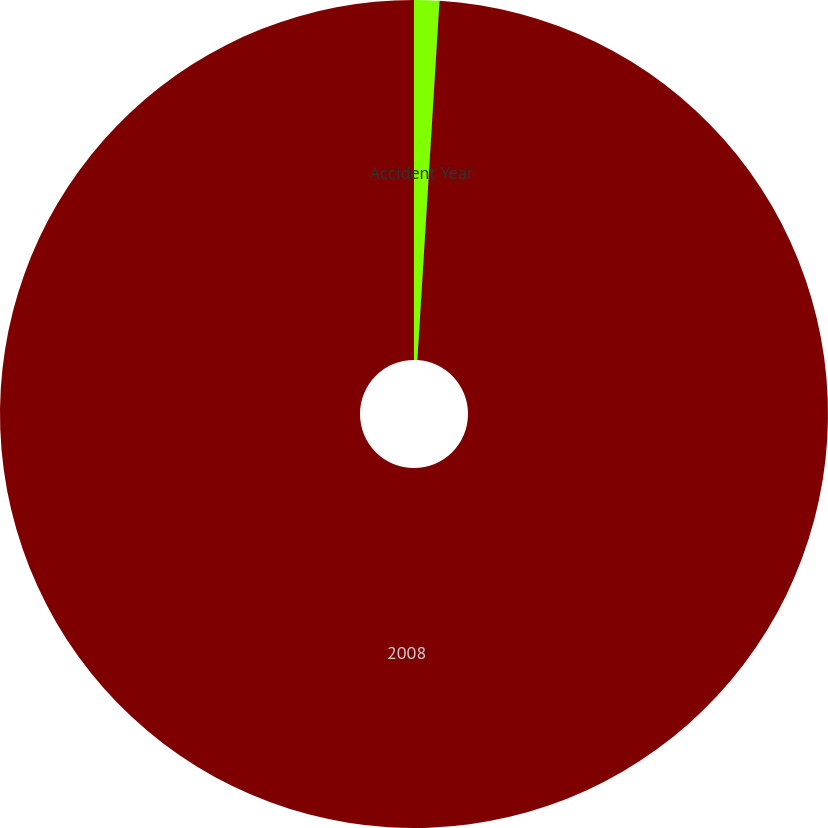<chart> <loc_0><loc_0><loc_500><loc_500><pie_chart><fcel>Accident Year<fcel>2008<nl><fcel>0.98%<fcel>99.02%<nl></chart> 